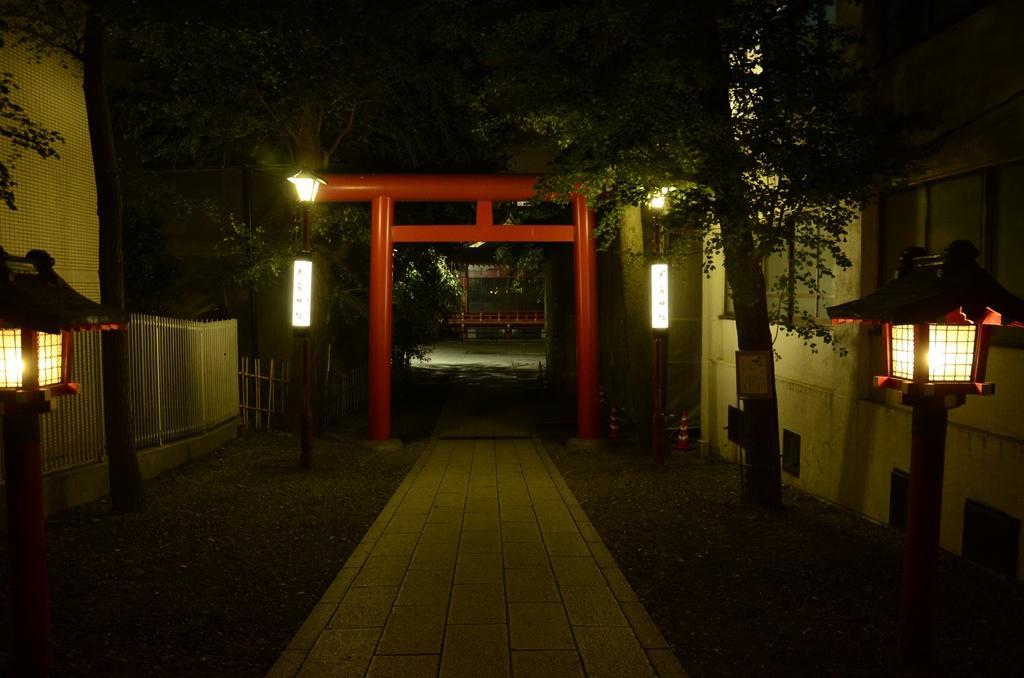Could you give a brief overview of what you see in this image? In this picture we can see an arch, path, light poles, trees, fence, traffic cones, buildings, windows and some objects. 